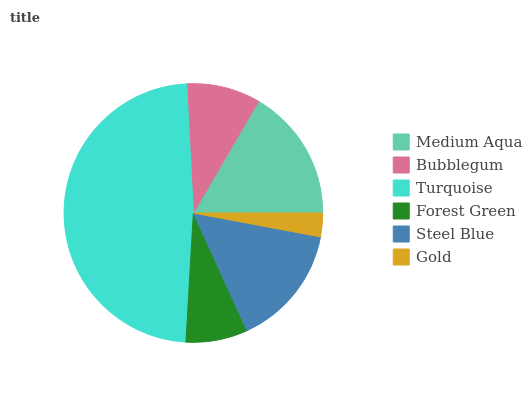Is Gold the minimum?
Answer yes or no. Yes. Is Turquoise the maximum?
Answer yes or no. Yes. Is Bubblegum the minimum?
Answer yes or no. No. Is Bubblegum the maximum?
Answer yes or no. No. Is Medium Aqua greater than Bubblegum?
Answer yes or no. Yes. Is Bubblegum less than Medium Aqua?
Answer yes or no. Yes. Is Bubblegum greater than Medium Aqua?
Answer yes or no. No. Is Medium Aqua less than Bubblegum?
Answer yes or no. No. Is Steel Blue the high median?
Answer yes or no. Yes. Is Bubblegum the low median?
Answer yes or no. Yes. Is Bubblegum the high median?
Answer yes or no. No. Is Medium Aqua the low median?
Answer yes or no. No. 